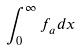Convert formula to latex. <formula><loc_0><loc_0><loc_500><loc_500>\int _ { 0 } ^ { \infty } f _ { a } d x</formula> 